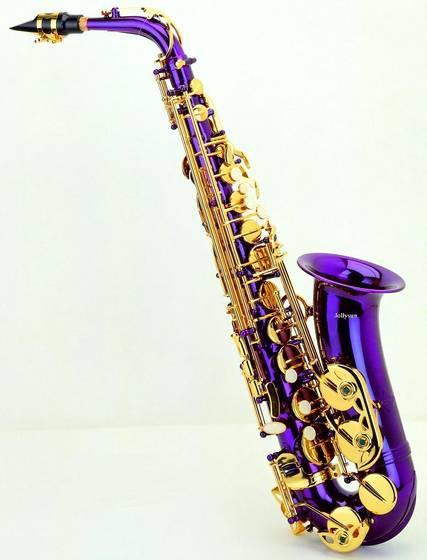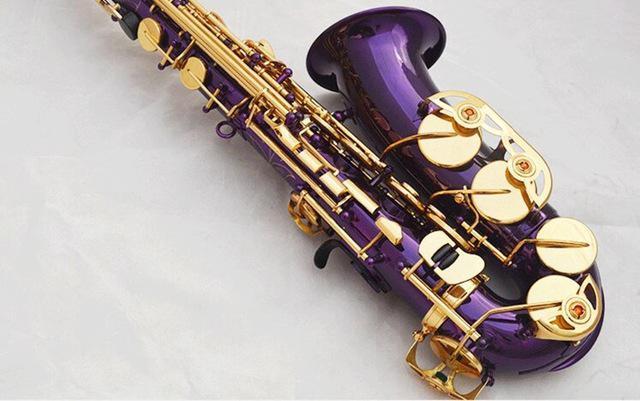The first image is the image on the left, the second image is the image on the right. Analyze the images presented: Is the assertion "You can see an entire saxophone in both photos." valid? Answer yes or no. No. 